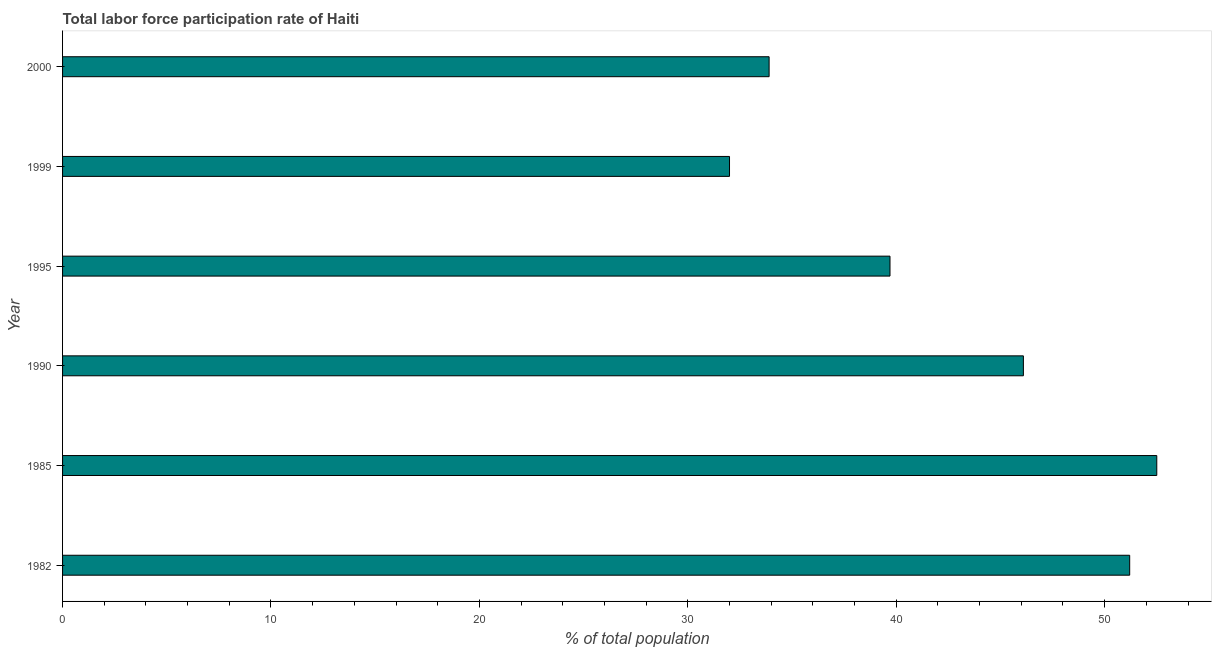Does the graph contain any zero values?
Your answer should be compact. No. What is the title of the graph?
Give a very brief answer. Total labor force participation rate of Haiti. What is the label or title of the X-axis?
Ensure brevity in your answer.  % of total population. What is the total labor force participation rate in 1990?
Offer a very short reply. 46.1. Across all years, what is the maximum total labor force participation rate?
Your answer should be compact. 52.5. In which year was the total labor force participation rate maximum?
Offer a terse response. 1985. What is the sum of the total labor force participation rate?
Ensure brevity in your answer.  255.4. What is the difference between the total labor force participation rate in 1995 and 1999?
Keep it short and to the point. 7.7. What is the average total labor force participation rate per year?
Your answer should be very brief. 42.57. What is the median total labor force participation rate?
Provide a succinct answer. 42.9. In how many years, is the total labor force participation rate greater than 40 %?
Provide a short and direct response. 3. What is the ratio of the total labor force participation rate in 1985 to that in 2000?
Offer a very short reply. 1.55. Is the total labor force participation rate in 1985 less than that in 1999?
Keep it short and to the point. No. What is the difference between the highest and the second highest total labor force participation rate?
Provide a succinct answer. 1.3. What is the difference between the highest and the lowest total labor force participation rate?
Keep it short and to the point. 20.5. Are all the bars in the graph horizontal?
Keep it short and to the point. Yes. What is the difference between two consecutive major ticks on the X-axis?
Ensure brevity in your answer.  10. What is the % of total population in 1982?
Your answer should be compact. 51.2. What is the % of total population of 1985?
Offer a terse response. 52.5. What is the % of total population in 1990?
Your response must be concise. 46.1. What is the % of total population in 1995?
Offer a terse response. 39.7. What is the % of total population of 1999?
Make the answer very short. 32. What is the % of total population of 2000?
Your answer should be compact. 33.9. What is the difference between the % of total population in 1982 and 1995?
Provide a succinct answer. 11.5. What is the difference between the % of total population in 1982 and 2000?
Your answer should be compact. 17.3. What is the difference between the % of total population in 1985 and 1999?
Give a very brief answer. 20.5. What is the difference between the % of total population in 1985 and 2000?
Make the answer very short. 18.6. What is the difference between the % of total population in 1990 and 2000?
Your response must be concise. 12.2. What is the difference between the % of total population in 1995 and 1999?
Make the answer very short. 7.7. What is the ratio of the % of total population in 1982 to that in 1990?
Ensure brevity in your answer.  1.11. What is the ratio of the % of total population in 1982 to that in 1995?
Keep it short and to the point. 1.29. What is the ratio of the % of total population in 1982 to that in 1999?
Offer a terse response. 1.6. What is the ratio of the % of total population in 1982 to that in 2000?
Offer a terse response. 1.51. What is the ratio of the % of total population in 1985 to that in 1990?
Provide a succinct answer. 1.14. What is the ratio of the % of total population in 1985 to that in 1995?
Ensure brevity in your answer.  1.32. What is the ratio of the % of total population in 1985 to that in 1999?
Provide a succinct answer. 1.64. What is the ratio of the % of total population in 1985 to that in 2000?
Provide a succinct answer. 1.55. What is the ratio of the % of total population in 1990 to that in 1995?
Offer a very short reply. 1.16. What is the ratio of the % of total population in 1990 to that in 1999?
Give a very brief answer. 1.44. What is the ratio of the % of total population in 1990 to that in 2000?
Ensure brevity in your answer.  1.36. What is the ratio of the % of total population in 1995 to that in 1999?
Your response must be concise. 1.24. What is the ratio of the % of total population in 1995 to that in 2000?
Give a very brief answer. 1.17. What is the ratio of the % of total population in 1999 to that in 2000?
Your response must be concise. 0.94. 